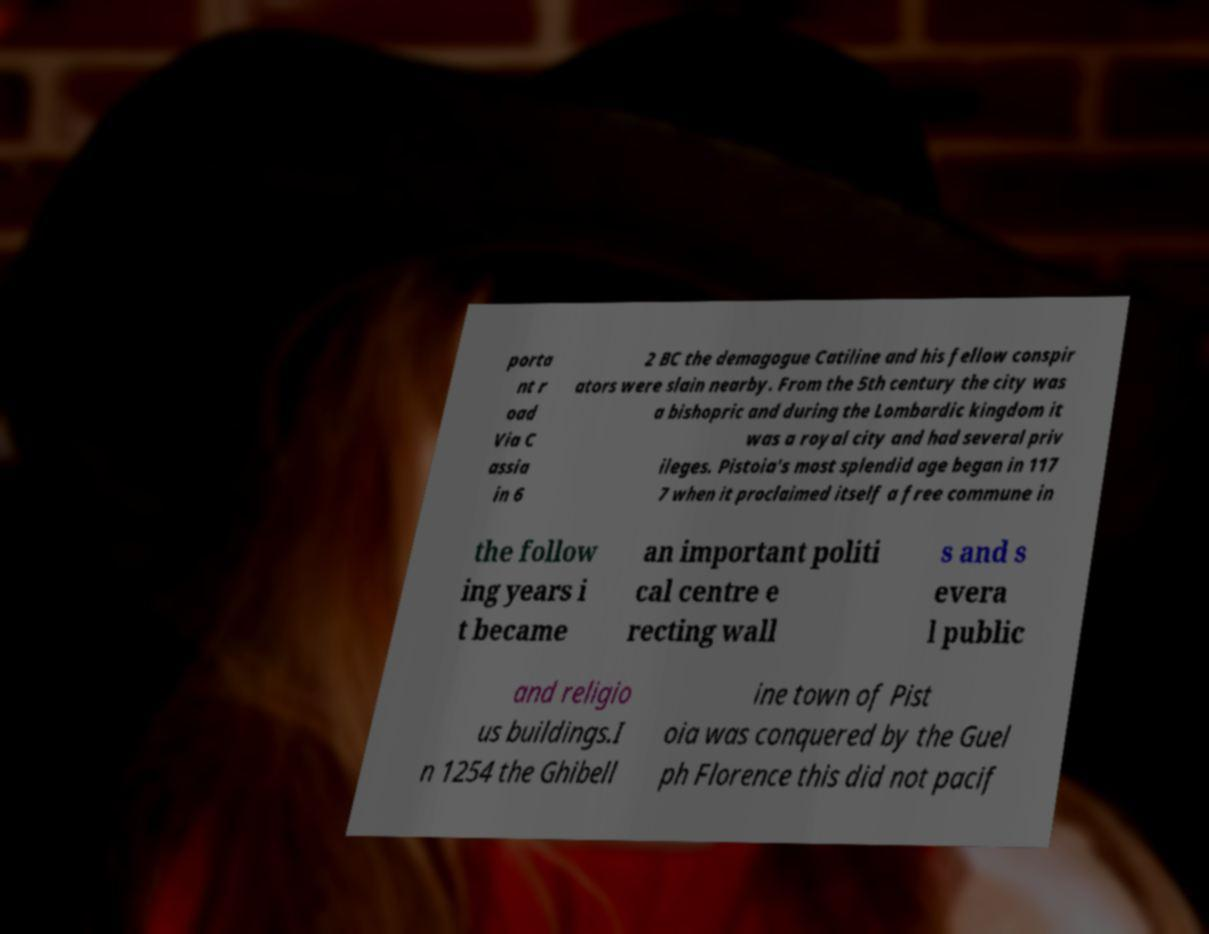Could you assist in decoding the text presented in this image and type it out clearly? porta nt r oad Via C assia in 6 2 BC the demagogue Catiline and his fellow conspir ators were slain nearby. From the 5th century the city was a bishopric and during the Lombardic kingdom it was a royal city and had several priv ileges. Pistoia's most splendid age began in 117 7 when it proclaimed itself a free commune in the follow ing years i t became an important politi cal centre e recting wall s and s evera l public and religio us buildings.I n 1254 the Ghibell ine town of Pist oia was conquered by the Guel ph Florence this did not pacif 